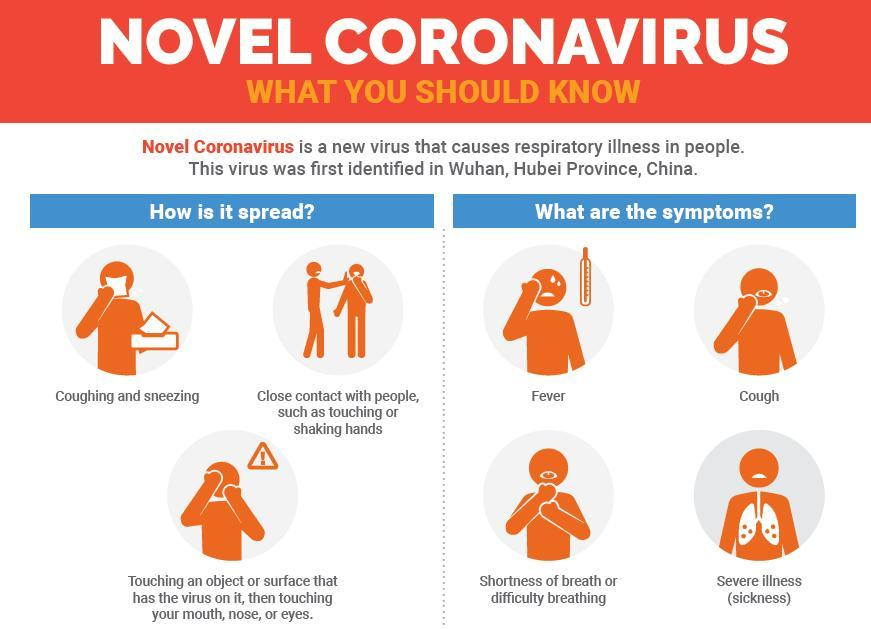how many ways of disease spreading are given in this infographic?
Answer the question with a short phrase. 3 What are the symptoms of coronavirus given at the top section of the graphics? fever, cough What are the symptoms of coronavirus apart from shortness of breath? fever, cough, severe illness(sickness) how many symptoms of Coronavirus are given in this infographic? 4 Number of times the word "novel coronavirus" appeared in this infographics is? 2 